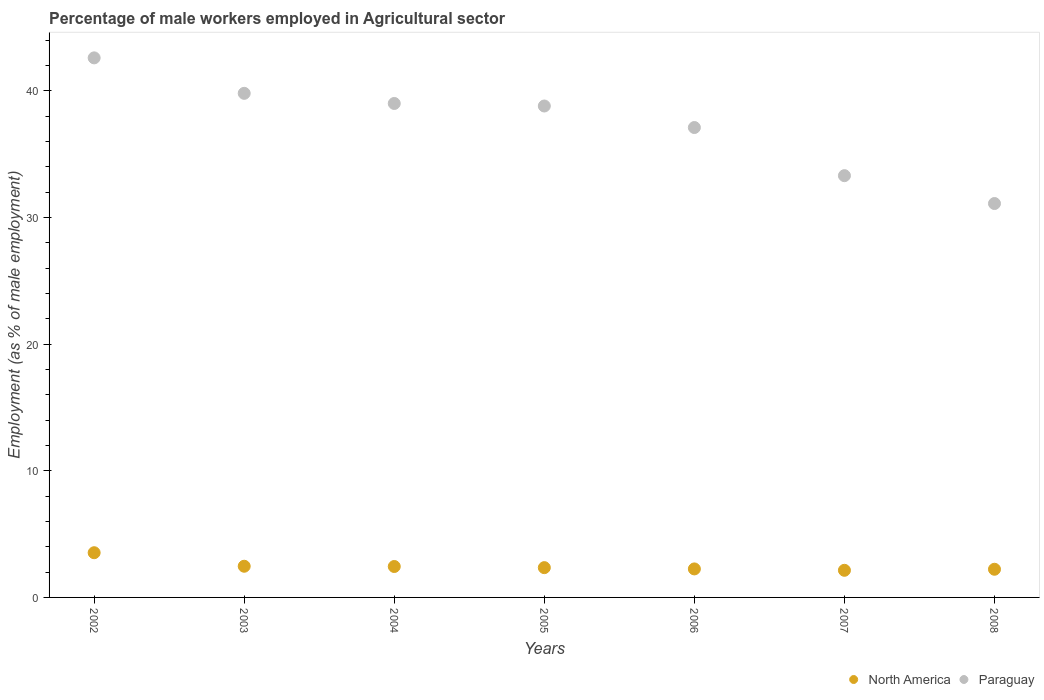How many different coloured dotlines are there?
Offer a very short reply. 2. What is the percentage of male workers employed in Agricultural sector in North America in 2004?
Provide a short and direct response. 2.44. Across all years, what is the maximum percentage of male workers employed in Agricultural sector in North America?
Provide a succinct answer. 3.53. Across all years, what is the minimum percentage of male workers employed in Agricultural sector in Paraguay?
Provide a short and direct response. 31.1. In which year was the percentage of male workers employed in Agricultural sector in Paraguay maximum?
Ensure brevity in your answer.  2002. In which year was the percentage of male workers employed in Agricultural sector in North America minimum?
Your answer should be compact. 2007. What is the total percentage of male workers employed in Agricultural sector in Paraguay in the graph?
Keep it short and to the point. 261.7. What is the difference between the percentage of male workers employed in Agricultural sector in Paraguay in 2004 and that in 2007?
Your answer should be compact. 5.7. What is the difference between the percentage of male workers employed in Agricultural sector in North America in 2005 and the percentage of male workers employed in Agricultural sector in Paraguay in 2007?
Offer a terse response. -30.95. What is the average percentage of male workers employed in Agricultural sector in North America per year?
Ensure brevity in your answer.  2.49. In the year 2006, what is the difference between the percentage of male workers employed in Agricultural sector in Paraguay and percentage of male workers employed in Agricultural sector in North America?
Offer a terse response. 34.85. In how many years, is the percentage of male workers employed in Agricultural sector in North America greater than 14 %?
Offer a very short reply. 0. What is the ratio of the percentage of male workers employed in Agricultural sector in North America in 2002 to that in 2008?
Make the answer very short. 1.59. What is the difference between the highest and the second highest percentage of male workers employed in Agricultural sector in North America?
Provide a short and direct response. 1.07. What is the difference between the highest and the lowest percentage of male workers employed in Agricultural sector in North America?
Your response must be concise. 1.39. Is the sum of the percentage of male workers employed in Agricultural sector in Paraguay in 2003 and 2007 greater than the maximum percentage of male workers employed in Agricultural sector in North America across all years?
Offer a very short reply. Yes. How many dotlines are there?
Offer a very short reply. 2. How many years are there in the graph?
Offer a terse response. 7. Does the graph contain any zero values?
Your response must be concise. No. Where does the legend appear in the graph?
Provide a short and direct response. Bottom right. How are the legend labels stacked?
Your answer should be compact. Horizontal. What is the title of the graph?
Keep it short and to the point. Percentage of male workers employed in Agricultural sector. Does "Montenegro" appear as one of the legend labels in the graph?
Provide a succinct answer. No. What is the label or title of the Y-axis?
Make the answer very short. Employment (as % of male employment). What is the Employment (as % of male employment) in North America in 2002?
Your answer should be compact. 3.53. What is the Employment (as % of male employment) of Paraguay in 2002?
Give a very brief answer. 42.6. What is the Employment (as % of male employment) of North America in 2003?
Your answer should be compact. 2.46. What is the Employment (as % of male employment) of Paraguay in 2003?
Your answer should be compact. 39.8. What is the Employment (as % of male employment) of North America in 2004?
Give a very brief answer. 2.44. What is the Employment (as % of male employment) in North America in 2005?
Offer a terse response. 2.35. What is the Employment (as % of male employment) in Paraguay in 2005?
Make the answer very short. 38.8. What is the Employment (as % of male employment) of North America in 2006?
Provide a short and direct response. 2.25. What is the Employment (as % of male employment) of Paraguay in 2006?
Give a very brief answer. 37.1. What is the Employment (as % of male employment) of North America in 2007?
Offer a very short reply. 2.14. What is the Employment (as % of male employment) of Paraguay in 2007?
Offer a terse response. 33.3. What is the Employment (as % of male employment) in North America in 2008?
Provide a short and direct response. 2.22. What is the Employment (as % of male employment) of Paraguay in 2008?
Make the answer very short. 31.1. Across all years, what is the maximum Employment (as % of male employment) in North America?
Your response must be concise. 3.53. Across all years, what is the maximum Employment (as % of male employment) in Paraguay?
Keep it short and to the point. 42.6. Across all years, what is the minimum Employment (as % of male employment) in North America?
Provide a succinct answer. 2.14. Across all years, what is the minimum Employment (as % of male employment) in Paraguay?
Offer a terse response. 31.1. What is the total Employment (as % of male employment) in North America in the graph?
Ensure brevity in your answer.  17.4. What is the total Employment (as % of male employment) in Paraguay in the graph?
Provide a succinct answer. 261.7. What is the difference between the Employment (as % of male employment) in North America in 2002 and that in 2003?
Offer a very short reply. 1.07. What is the difference between the Employment (as % of male employment) of North America in 2002 and that in 2004?
Offer a very short reply. 1.09. What is the difference between the Employment (as % of male employment) of Paraguay in 2002 and that in 2004?
Your answer should be very brief. 3.6. What is the difference between the Employment (as % of male employment) of North America in 2002 and that in 2005?
Provide a short and direct response. 1.18. What is the difference between the Employment (as % of male employment) of North America in 2002 and that in 2006?
Offer a terse response. 1.28. What is the difference between the Employment (as % of male employment) in Paraguay in 2002 and that in 2006?
Ensure brevity in your answer.  5.5. What is the difference between the Employment (as % of male employment) of North America in 2002 and that in 2007?
Your answer should be very brief. 1.39. What is the difference between the Employment (as % of male employment) of Paraguay in 2002 and that in 2007?
Your response must be concise. 9.3. What is the difference between the Employment (as % of male employment) of North America in 2002 and that in 2008?
Your answer should be compact. 1.31. What is the difference between the Employment (as % of male employment) in North America in 2003 and that in 2004?
Keep it short and to the point. 0.02. What is the difference between the Employment (as % of male employment) of Paraguay in 2003 and that in 2004?
Provide a short and direct response. 0.8. What is the difference between the Employment (as % of male employment) of North America in 2003 and that in 2005?
Offer a terse response. 0.11. What is the difference between the Employment (as % of male employment) in North America in 2003 and that in 2006?
Ensure brevity in your answer.  0.21. What is the difference between the Employment (as % of male employment) in Paraguay in 2003 and that in 2006?
Provide a short and direct response. 2.7. What is the difference between the Employment (as % of male employment) of North America in 2003 and that in 2007?
Provide a succinct answer. 0.32. What is the difference between the Employment (as % of male employment) in North America in 2003 and that in 2008?
Your answer should be very brief. 0.24. What is the difference between the Employment (as % of male employment) in Paraguay in 2003 and that in 2008?
Keep it short and to the point. 8.7. What is the difference between the Employment (as % of male employment) of North America in 2004 and that in 2005?
Keep it short and to the point. 0.09. What is the difference between the Employment (as % of male employment) in North America in 2004 and that in 2006?
Make the answer very short. 0.19. What is the difference between the Employment (as % of male employment) of Paraguay in 2004 and that in 2006?
Your response must be concise. 1.9. What is the difference between the Employment (as % of male employment) of North America in 2004 and that in 2007?
Provide a short and direct response. 0.3. What is the difference between the Employment (as % of male employment) in North America in 2004 and that in 2008?
Provide a short and direct response. 0.22. What is the difference between the Employment (as % of male employment) of Paraguay in 2004 and that in 2008?
Offer a very short reply. 7.9. What is the difference between the Employment (as % of male employment) in North America in 2005 and that in 2006?
Provide a succinct answer. 0.1. What is the difference between the Employment (as % of male employment) of Paraguay in 2005 and that in 2006?
Ensure brevity in your answer.  1.7. What is the difference between the Employment (as % of male employment) of North America in 2005 and that in 2007?
Your answer should be very brief. 0.21. What is the difference between the Employment (as % of male employment) of North America in 2005 and that in 2008?
Your response must be concise. 0.13. What is the difference between the Employment (as % of male employment) of Paraguay in 2005 and that in 2008?
Ensure brevity in your answer.  7.7. What is the difference between the Employment (as % of male employment) in North America in 2006 and that in 2007?
Ensure brevity in your answer.  0.11. What is the difference between the Employment (as % of male employment) of Paraguay in 2006 and that in 2007?
Ensure brevity in your answer.  3.8. What is the difference between the Employment (as % of male employment) of North America in 2006 and that in 2008?
Your answer should be very brief. 0.03. What is the difference between the Employment (as % of male employment) of North America in 2007 and that in 2008?
Offer a terse response. -0.08. What is the difference between the Employment (as % of male employment) in Paraguay in 2007 and that in 2008?
Provide a short and direct response. 2.2. What is the difference between the Employment (as % of male employment) of North America in 2002 and the Employment (as % of male employment) of Paraguay in 2003?
Give a very brief answer. -36.27. What is the difference between the Employment (as % of male employment) of North America in 2002 and the Employment (as % of male employment) of Paraguay in 2004?
Ensure brevity in your answer.  -35.47. What is the difference between the Employment (as % of male employment) of North America in 2002 and the Employment (as % of male employment) of Paraguay in 2005?
Offer a terse response. -35.27. What is the difference between the Employment (as % of male employment) in North America in 2002 and the Employment (as % of male employment) in Paraguay in 2006?
Offer a very short reply. -33.57. What is the difference between the Employment (as % of male employment) in North America in 2002 and the Employment (as % of male employment) in Paraguay in 2007?
Give a very brief answer. -29.77. What is the difference between the Employment (as % of male employment) of North America in 2002 and the Employment (as % of male employment) of Paraguay in 2008?
Provide a short and direct response. -27.57. What is the difference between the Employment (as % of male employment) of North America in 2003 and the Employment (as % of male employment) of Paraguay in 2004?
Ensure brevity in your answer.  -36.54. What is the difference between the Employment (as % of male employment) in North America in 2003 and the Employment (as % of male employment) in Paraguay in 2005?
Your answer should be compact. -36.34. What is the difference between the Employment (as % of male employment) in North America in 2003 and the Employment (as % of male employment) in Paraguay in 2006?
Offer a terse response. -34.64. What is the difference between the Employment (as % of male employment) of North America in 2003 and the Employment (as % of male employment) of Paraguay in 2007?
Give a very brief answer. -30.84. What is the difference between the Employment (as % of male employment) in North America in 2003 and the Employment (as % of male employment) in Paraguay in 2008?
Provide a succinct answer. -28.64. What is the difference between the Employment (as % of male employment) of North America in 2004 and the Employment (as % of male employment) of Paraguay in 2005?
Your answer should be very brief. -36.36. What is the difference between the Employment (as % of male employment) of North America in 2004 and the Employment (as % of male employment) of Paraguay in 2006?
Make the answer very short. -34.66. What is the difference between the Employment (as % of male employment) in North America in 2004 and the Employment (as % of male employment) in Paraguay in 2007?
Make the answer very short. -30.86. What is the difference between the Employment (as % of male employment) of North America in 2004 and the Employment (as % of male employment) of Paraguay in 2008?
Provide a succinct answer. -28.66. What is the difference between the Employment (as % of male employment) of North America in 2005 and the Employment (as % of male employment) of Paraguay in 2006?
Your answer should be compact. -34.75. What is the difference between the Employment (as % of male employment) in North America in 2005 and the Employment (as % of male employment) in Paraguay in 2007?
Your answer should be compact. -30.95. What is the difference between the Employment (as % of male employment) of North America in 2005 and the Employment (as % of male employment) of Paraguay in 2008?
Make the answer very short. -28.75. What is the difference between the Employment (as % of male employment) of North America in 2006 and the Employment (as % of male employment) of Paraguay in 2007?
Your answer should be compact. -31.05. What is the difference between the Employment (as % of male employment) of North America in 2006 and the Employment (as % of male employment) of Paraguay in 2008?
Offer a very short reply. -28.85. What is the difference between the Employment (as % of male employment) in North America in 2007 and the Employment (as % of male employment) in Paraguay in 2008?
Provide a succinct answer. -28.96. What is the average Employment (as % of male employment) in North America per year?
Make the answer very short. 2.49. What is the average Employment (as % of male employment) in Paraguay per year?
Keep it short and to the point. 37.39. In the year 2002, what is the difference between the Employment (as % of male employment) of North America and Employment (as % of male employment) of Paraguay?
Give a very brief answer. -39.07. In the year 2003, what is the difference between the Employment (as % of male employment) of North America and Employment (as % of male employment) of Paraguay?
Keep it short and to the point. -37.34. In the year 2004, what is the difference between the Employment (as % of male employment) in North America and Employment (as % of male employment) in Paraguay?
Ensure brevity in your answer.  -36.56. In the year 2005, what is the difference between the Employment (as % of male employment) in North America and Employment (as % of male employment) in Paraguay?
Provide a succinct answer. -36.45. In the year 2006, what is the difference between the Employment (as % of male employment) in North America and Employment (as % of male employment) in Paraguay?
Provide a short and direct response. -34.85. In the year 2007, what is the difference between the Employment (as % of male employment) in North America and Employment (as % of male employment) in Paraguay?
Give a very brief answer. -31.16. In the year 2008, what is the difference between the Employment (as % of male employment) in North America and Employment (as % of male employment) in Paraguay?
Your answer should be very brief. -28.88. What is the ratio of the Employment (as % of male employment) in North America in 2002 to that in 2003?
Give a very brief answer. 1.43. What is the ratio of the Employment (as % of male employment) in Paraguay in 2002 to that in 2003?
Provide a short and direct response. 1.07. What is the ratio of the Employment (as % of male employment) in North America in 2002 to that in 2004?
Provide a short and direct response. 1.45. What is the ratio of the Employment (as % of male employment) in Paraguay in 2002 to that in 2004?
Provide a short and direct response. 1.09. What is the ratio of the Employment (as % of male employment) of North America in 2002 to that in 2005?
Make the answer very short. 1.5. What is the ratio of the Employment (as % of male employment) of Paraguay in 2002 to that in 2005?
Your answer should be very brief. 1.1. What is the ratio of the Employment (as % of male employment) of North America in 2002 to that in 2006?
Your response must be concise. 1.57. What is the ratio of the Employment (as % of male employment) of Paraguay in 2002 to that in 2006?
Offer a very short reply. 1.15. What is the ratio of the Employment (as % of male employment) of North America in 2002 to that in 2007?
Keep it short and to the point. 1.65. What is the ratio of the Employment (as % of male employment) of Paraguay in 2002 to that in 2007?
Provide a succinct answer. 1.28. What is the ratio of the Employment (as % of male employment) of North America in 2002 to that in 2008?
Your answer should be compact. 1.59. What is the ratio of the Employment (as % of male employment) of Paraguay in 2002 to that in 2008?
Offer a terse response. 1.37. What is the ratio of the Employment (as % of male employment) of North America in 2003 to that in 2004?
Provide a succinct answer. 1.01. What is the ratio of the Employment (as % of male employment) of Paraguay in 2003 to that in 2004?
Offer a terse response. 1.02. What is the ratio of the Employment (as % of male employment) of North America in 2003 to that in 2005?
Your answer should be very brief. 1.05. What is the ratio of the Employment (as % of male employment) of Paraguay in 2003 to that in 2005?
Keep it short and to the point. 1.03. What is the ratio of the Employment (as % of male employment) in North America in 2003 to that in 2006?
Your response must be concise. 1.09. What is the ratio of the Employment (as % of male employment) of Paraguay in 2003 to that in 2006?
Offer a very short reply. 1.07. What is the ratio of the Employment (as % of male employment) of North America in 2003 to that in 2007?
Your answer should be very brief. 1.15. What is the ratio of the Employment (as % of male employment) in Paraguay in 2003 to that in 2007?
Offer a terse response. 1.2. What is the ratio of the Employment (as % of male employment) in North America in 2003 to that in 2008?
Keep it short and to the point. 1.11. What is the ratio of the Employment (as % of male employment) in Paraguay in 2003 to that in 2008?
Provide a succinct answer. 1.28. What is the ratio of the Employment (as % of male employment) in North America in 2004 to that in 2005?
Give a very brief answer. 1.04. What is the ratio of the Employment (as % of male employment) in Paraguay in 2004 to that in 2005?
Make the answer very short. 1.01. What is the ratio of the Employment (as % of male employment) of North America in 2004 to that in 2006?
Your response must be concise. 1.08. What is the ratio of the Employment (as % of male employment) of Paraguay in 2004 to that in 2006?
Your answer should be very brief. 1.05. What is the ratio of the Employment (as % of male employment) of North America in 2004 to that in 2007?
Make the answer very short. 1.14. What is the ratio of the Employment (as % of male employment) in Paraguay in 2004 to that in 2007?
Ensure brevity in your answer.  1.17. What is the ratio of the Employment (as % of male employment) in North America in 2004 to that in 2008?
Offer a very short reply. 1.1. What is the ratio of the Employment (as % of male employment) of Paraguay in 2004 to that in 2008?
Keep it short and to the point. 1.25. What is the ratio of the Employment (as % of male employment) in North America in 2005 to that in 2006?
Make the answer very short. 1.04. What is the ratio of the Employment (as % of male employment) of Paraguay in 2005 to that in 2006?
Your response must be concise. 1.05. What is the ratio of the Employment (as % of male employment) in North America in 2005 to that in 2007?
Offer a very short reply. 1.1. What is the ratio of the Employment (as % of male employment) of Paraguay in 2005 to that in 2007?
Provide a short and direct response. 1.17. What is the ratio of the Employment (as % of male employment) in North America in 2005 to that in 2008?
Give a very brief answer. 1.06. What is the ratio of the Employment (as % of male employment) of Paraguay in 2005 to that in 2008?
Make the answer very short. 1.25. What is the ratio of the Employment (as % of male employment) of North America in 2006 to that in 2007?
Your answer should be compact. 1.05. What is the ratio of the Employment (as % of male employment) of Paraguay in 2006 to that in 2007?
Offer a very short reply. 1.11. What is the ratio of the Employment (as % of male employment) in North America in 2006 to that in 2008?
Your answer should be compact. 1.01. What is the ratio of the Employment (as % of male employment) in Paraguay in 2006 to that in 2008?
Your answer should be very brief. 1.19. What is the ratio of the Employment (as % of male employment) in North America in 2007 to that in 2008?
Your answer should be very brief. 0.96. What is the ratio of the Employment (as % of male employment) of Paraguay in 2007 to that in 2008?
Your response must be concise. 1.07. What is the difference between the highest and the second highest Employment (as % of male employment) in North America?
Your answer should be compact. 1.07. What is the difference between the highest and the lowest Employment (as % of male employment) of North America?
Your answer should be compact. 1.39. What is the difference between the highest and the lowest Employment (as % of male employment) of Paraguay?
Your answer should be very brief. 11.5. 